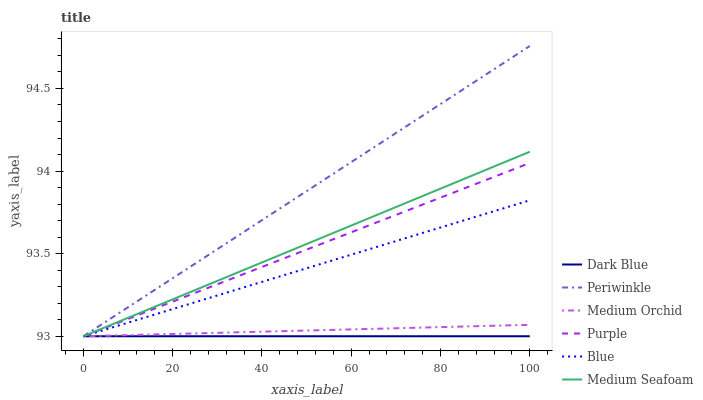Does Purple have the minimum area under the curve?
Answer yes or no. No. Does Purple have the maximum area under the curve?
Answer yes or no. No. Is Purple the smoothest?
Answer yes or no. No. Is Purple the roughest?
Answer yes or no. No. Does Purple have the highest value?
Answer yes or no. No. 